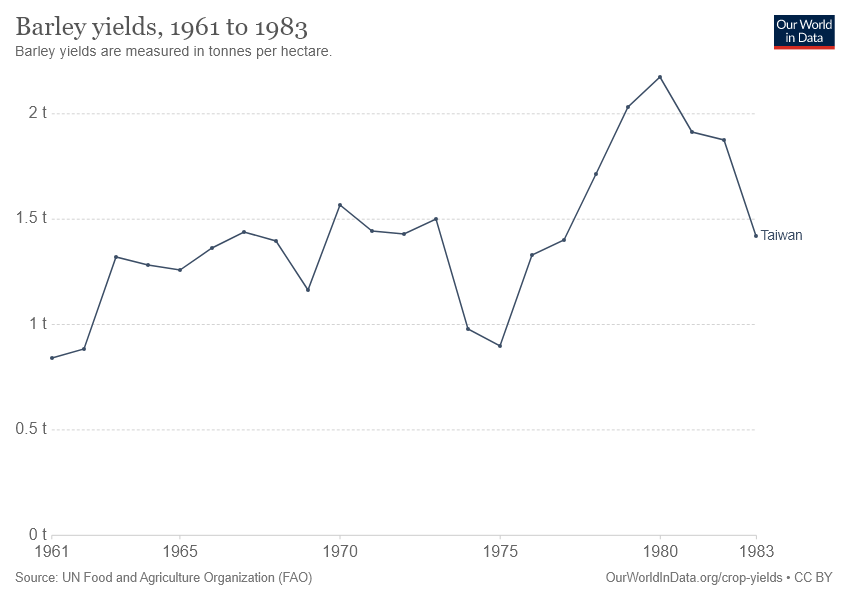Identify some key points in this picture. The line reached its peak in 1980. The line has the sharpest increase between the years 1961 and 1965. 